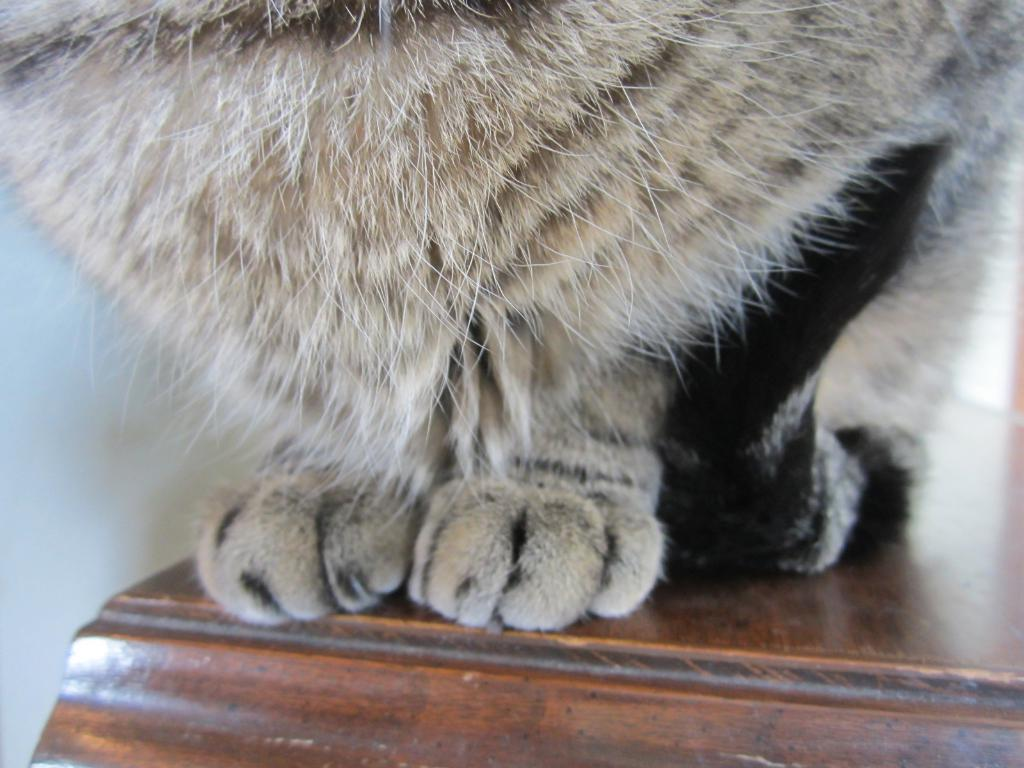What is on the table in the image? There is an animal on the table in the image. What can be seen in the background of the image? There is a wall visible in the image. What type of rock can be seen playing with the kitten in the image? There is no rock or kitten present in the image. 